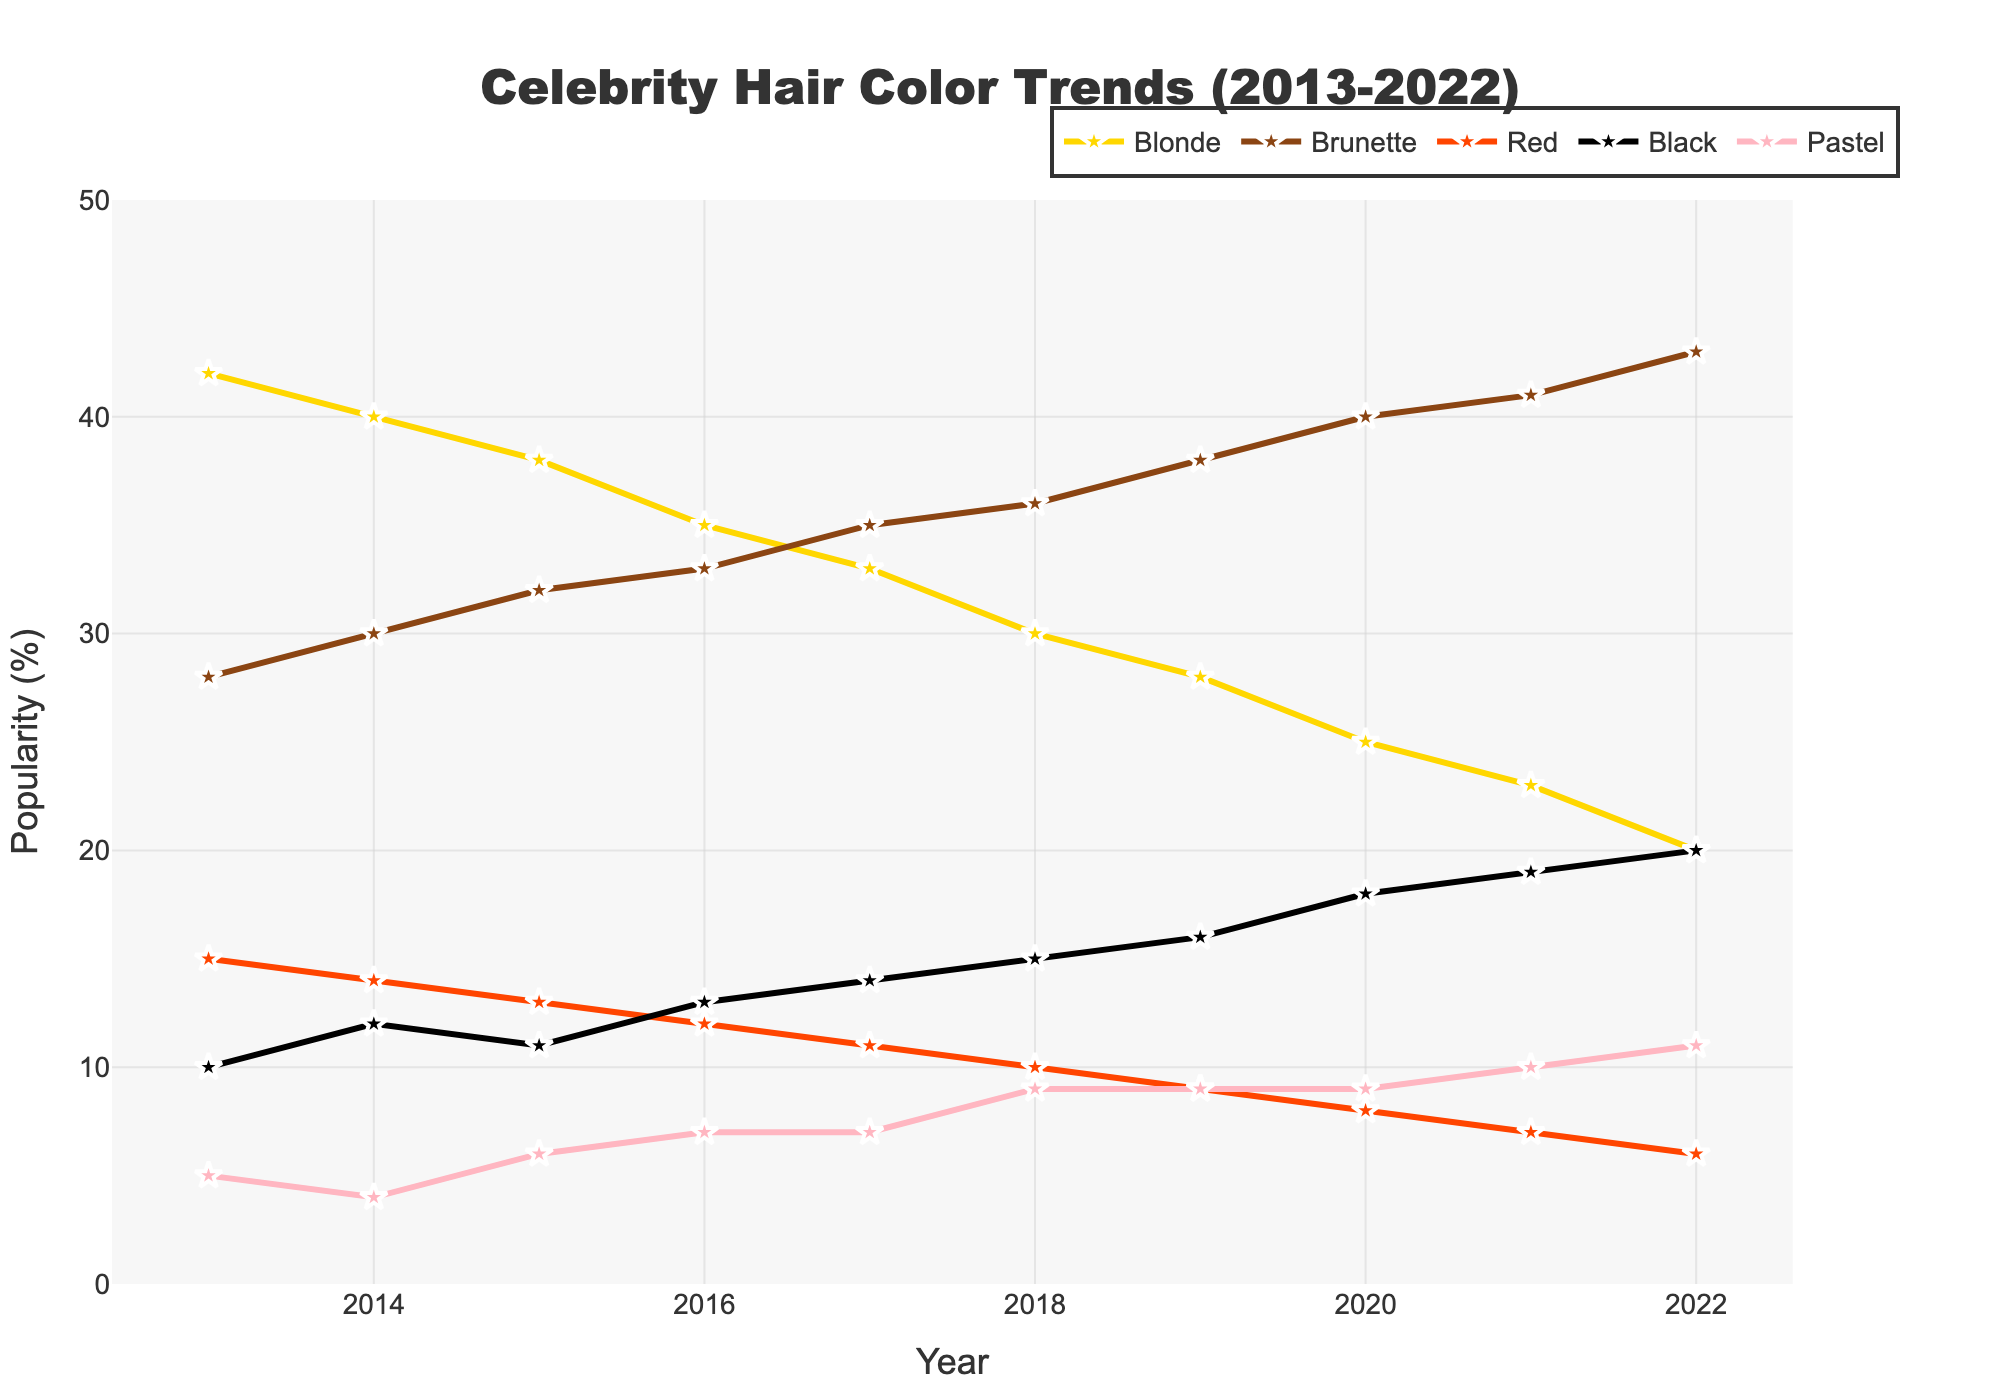What's the most popular hair color among A-list celebrities in 2022? Look at the data points for 2022 and identify the hair color with the highest value. Brunette has a value of 43, which is higher than all other colors.
Answer: Brunette Which hair color showed the largest decrease in popularity from 2013 to 2022? Calculate the difference in popularity for each color between 2013 and 2022. Blonde decreased from 42 to 20, which is a drop of 22, the largest among all colors.
Answer: Blonde In what year did Black hair color surpass Red hair color in popularity? Examine the intersecting points of the lines representing Black and Red colors. In 2014, Black surpassed Red with 12 compared to 14.
Answer: 2014 How much more popular was Blonde hair compared to Pastel in 2013? Look at the values for Blonde and Pastel in 2013 and subtract the popularity of Pastel from Blonde. Blonde was at 42 and Pastel at 5, the difference is 42 - 5 = 37.
Answer: 37 Which hair color has shown a consistent increase in popularity over the entire period? Identify the hair color whose trend line shows an upward trajectory from 2013 to 2022 without any decrease. Brunette shows consistent increase from 28 to 43.
Answer: Brunette On average, how did the popularity of Red hair change per year from 2013 to 2022? Calculate the total change in popularity of Red hair from 2013 to 2022 and divide by the number of years. Red went from 15 to 6, a change of -9 over 9 years, averaging -1 per year.
Answer: -1 per year Which hair color became equally popular to Black hair in any year? Find any intersecting points from the lines of different hair colors with the Black hair line. In 2018, both Black and Pastel were equal at 15%.
Answer: Pastel in 2018 Which year saw the largest increase in the popularity of Black hair color? Examine the data points year by year and observe the differences. Black saw the largest increase from 2019 to 2020, going from 16 to 18%.
Answer: 2020 How does the popularity of Brunette hair in 2020 compare to the popularity of Blonde hair in 2013? Compare the values directly from the chart; Brunette in 2020 is at 40, while Blonde in 2013 is at 42.
Answer: Slightly less in 2020 When was Pastel hair more popular than Red hair? Look for years where the value for Pastel exceeds that of Red. From 2018 onwards, Pastel is more popular than Red.
Answer: 2018 onwards 